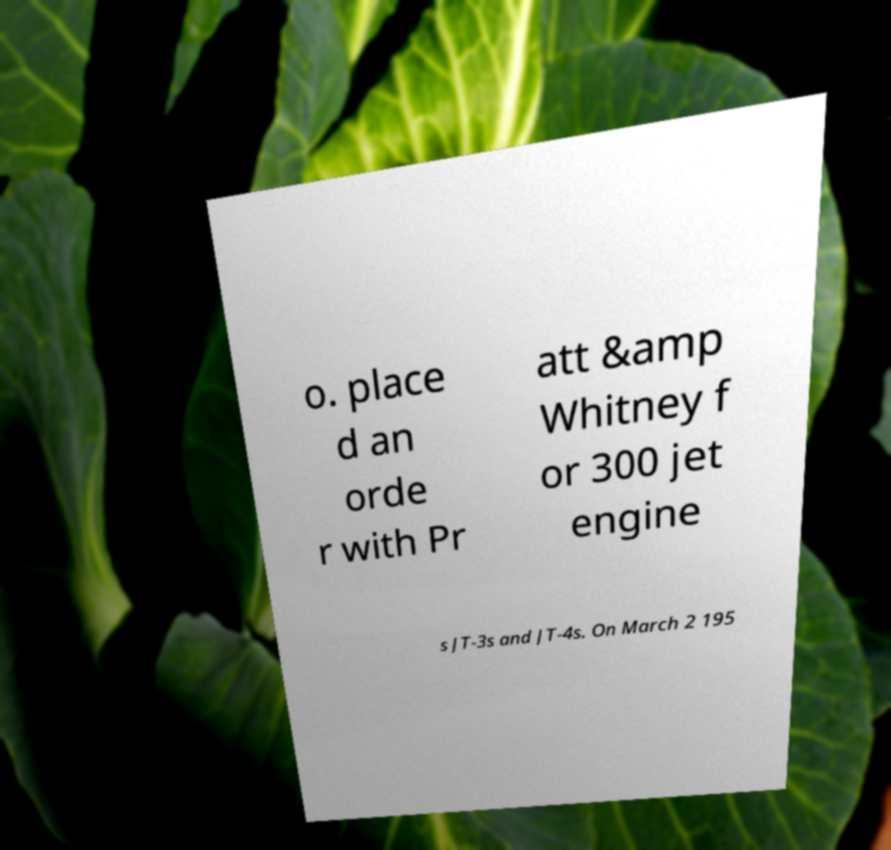Could you extract and type out the text from this image? o. place d an orde r with Pr att &amp Whitney f or 300 jet engine s JT-3s and JT-4s. On March 2 195 